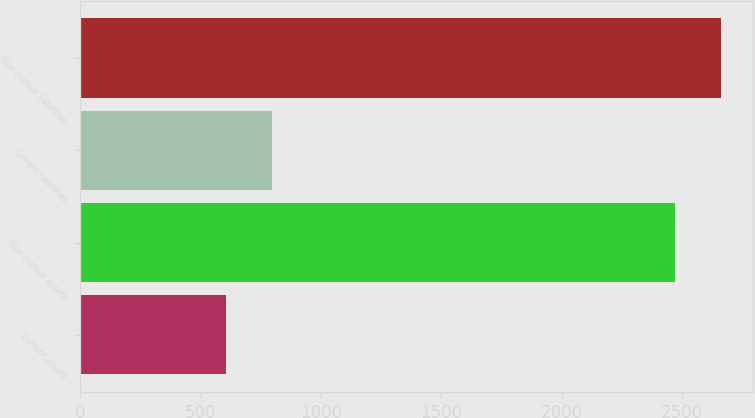<chart> <loc_0><loc_0><loc_500><loc_500><bar_chart><fcel>Current assets<fcel>Non-current assets<fcel>Current liabilities<fcel>Non-current liabilities<nl><fcel>605<fcel>2470<fcel>797.9<fcel>2662.9<nl></chart> 